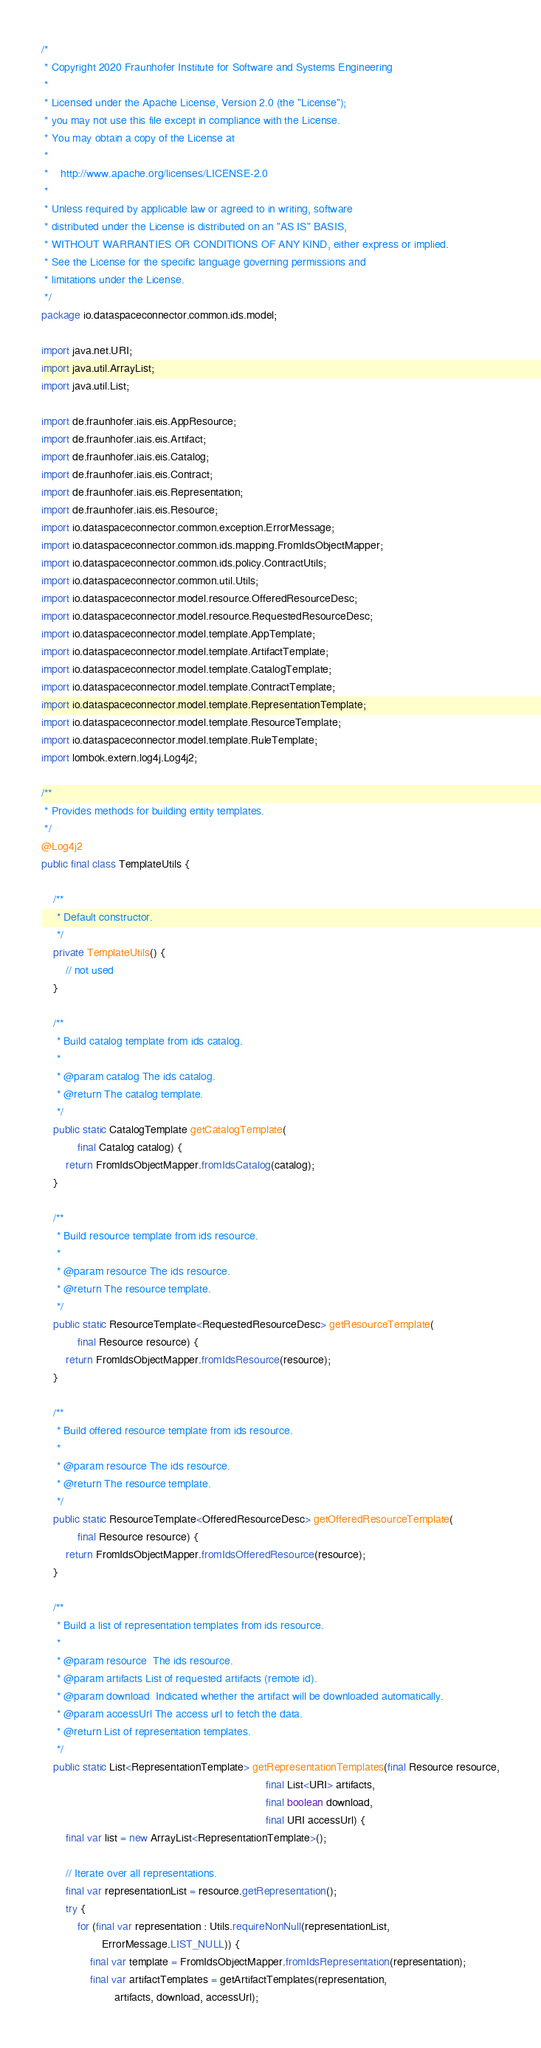Convert code to text. <code><loc_0><loc_0><loc_500><loc_500><_Java_>/*
 * Copyright 2020 Fraunhofer Institute for Software and Systems Engineering
 *
 * Licensed under the Apache License, Version 2.0 (the "License");
 * you may not use this file except in compliance with the License.
 * You may obtain a copy of the License at
 *
 *    http://www.apache.org/licenses/LICENSE-2.0
 *
 * Unless required by applicable law or agreed to in writing, software
 * distributed under the License is distributed on an "AS IS" BASIS,
 * WITHOUT WARRANTIES OR CONDITIONS OF ANY KIND, either express or implied.
 * See the License for the specific language governing permissions and
 * limitations under the License.
 */
package io.dataspaceconnector.common.ids.model;

import java.net.URI;
import java.util.ArrayList;
import java.util.List;

import de.fraunhofer.iais.eis.AppResource;
import de.fraunhofer.iais.eis.Artifact;
import de.fraunhofer.iais.eis.Catalog;
import de.fraunhofer.iais.eis.Contract;
import de.fraunhofer.iais.eis.Representation;
import de.fraunhofer.iais.eis.Resource;
import io.dataspaceconnector.common.exception.ErrorMessage;
import io.dataspaceconnector.common.ids.mapping.FromIdsObjectMapper;
import io.dataspaceconnector.common.ids.policy.ContractUtils;
import io.dataspaceconnector.common.util.Utils;
import io.dataspaceconnector.model.resource.OfferedResourceDesc;
import io.dataspaceconnector.model.resource.RequestedResourceDesc;
import io.dataspaceconnector.model.template.AppTemplate;
import io.dataspaceconnector.model.template.ArtifactTemplate;
import io.dataspaceconnector.model.template.CatalogTemplate;
import io.dataspaceconnector.model.template.ContractTemplate;
import io.dataspaceconnector.model.template.RepresentationTemplate;
import io.dataspaceconnector.model.template.ResourceTemplate;
import io.dataspaceconnector.model.template.RuleTemplate;
import lombok.extern.log4j.Log4j2;

/**
 * Provides methods for building entity templates.
 */
@Log4j2
public final class TemplateUtils {

    /**
     * Default constructor.
     */
    private TemplateUtils() {
        // not used
    }

    /**
     * Build catalog template from ids catalog.
     *
     * @param catalog The ids catalog.
     * @return The catalog template.
     */
    public static CatalogTemplate getCatalogTemplate(
            final Catalog catalog) {
        return FromIdsObjectMapper.fromIdsCatalog(catalog);
    }

    /**
     * Build resource template from ids resource.
     *
     * @param resource The ids resource.
     * @return The resource template.
     */
    public static ResourceTemplate<RequestedResourceDesc> getResourceTemplate(
            final Resource resource) {
        return FromIdsObjectMapper.fromIdsResource(resource);
    }

    /**
     * Build offered resource template from ids resource.
     *
     * @param resource The ids resource.
     * @return The resource template.
     */
    public static ResourceTemplate<OfferedResourceDesc> getOfferedResourceTemplate(
            final Resource resource) {
        return FromIdsObjectMapper.fromIdsOfferedResource(resource);
    }

    /**
     * Build a list of representation templates from ids resource.
     *
     * @param resource  The ids resource.
     * @param artifacts List of requested artifacts (remote id).
     * @param download  Indicated whether the artifact will be downloaded automatically.
     * @param accessUrl The access url to fetch the data.
     * @return List of representation templates.
     */
    public static List<RepresentationTemplate> getRepresentationTemplates(final Resource resource,
                                                                          final List<URI> artifacts,
                                                                          final boolean download,
                                                                          final URI accessUrl) {
        final var list = new ArrayList<RepresentationTemplate>();

        // Iterate over all representations.
        final var representationList = resource.getRepresentation();
        try {
            for (final var representation : Utils.requireNonNull(representationList,
                    ErrorMessage.LIST_NULL)) {
                final var template = FromIdsObjectMapper.fromIdsRepresentation(representation);
                final var artifactTemplates = getArtifactTemplates(representation,
                        artifacts, download, accessUrl);
</code> 